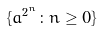Convert formula to latex. <formula><loc_0><loc_0><loc_500><loc_500>\{ a ^ { 2 ^ { n } } \colon n \geq 0 \}</formula> 